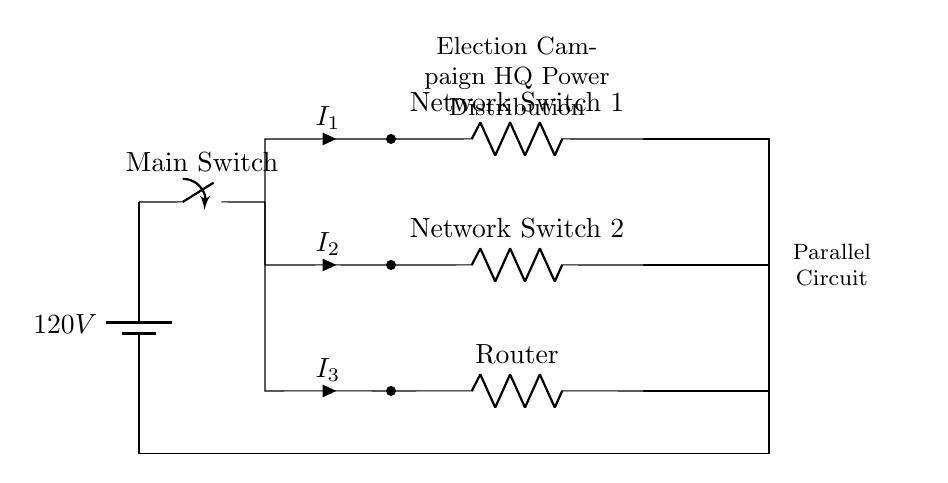What is the primary voltage of the circuit? The circuit consists of a battery labeled with a voltage of 120V, which indicates the potential difference supplied to the entire circuit.
Answer: 120V How many devices are connected in parallel? There are three devices connected in parallel: two network switches and one router, which are positioned in separate branches stemming from a common point.
Answer: Three What is the current flowing through Network Switch 1? The current labeled as I1 represents the flow through Network Switch 1; however, specific numerical values are not provided, thus it remains unknown unless additional information about the resistance or total current is given.
Answer: I1 What is the total current through the parallel circuit? In a parallel circuit, the total current is the sum of the individual branch currents (I1, I2, I3); still, without values for these currents, the total current cannot be quantified.
Answer: Total current = I1 + I2 + I3 What type of circuit is depicted? The circuit is specified as a parallel circuit in the labeling, which is characterized by multiple branches allowing different devices to operate independently from one another while receiving the same voltage.
Answer: Parallel What will happen if one of the network switches fails? If one of the network switches fails, only the branch where that switch is located will be affected, while the other branches (the other switch and the router) will continue to operate normally, demonstrating the resilience of parallel circuits.
Answer: Other devices remain operational 